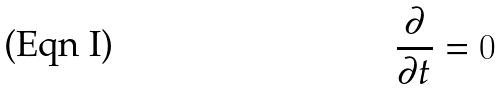<formula> <loc_0><loc_0><loc_500><loc_500>\frac { \partial } { \partial t } = 0</formula> 